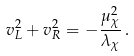Convert formula to latex. <formula><loc_0><loc_0><loc_500><loc_500>v _ { L } ^ { 2 } + v _ { R } ^ { 2 } = - \frac { \mu _ { \chi } ^ { 2 } } { \lambda _ { \chi } } \, .</formula> 